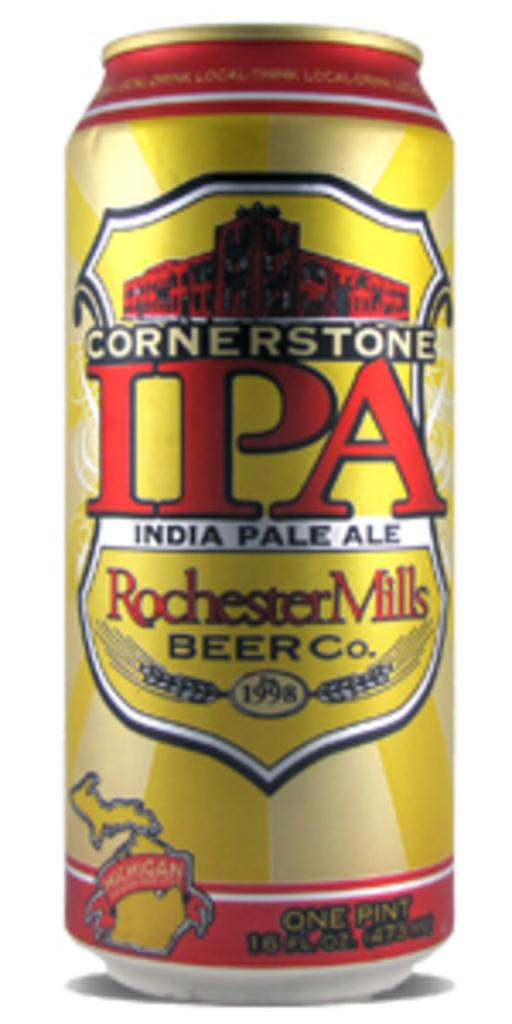<image>
Write a terse but informative summary of the picture. A can of Cornerstone IPA from Rochester Mills Beer Company. 